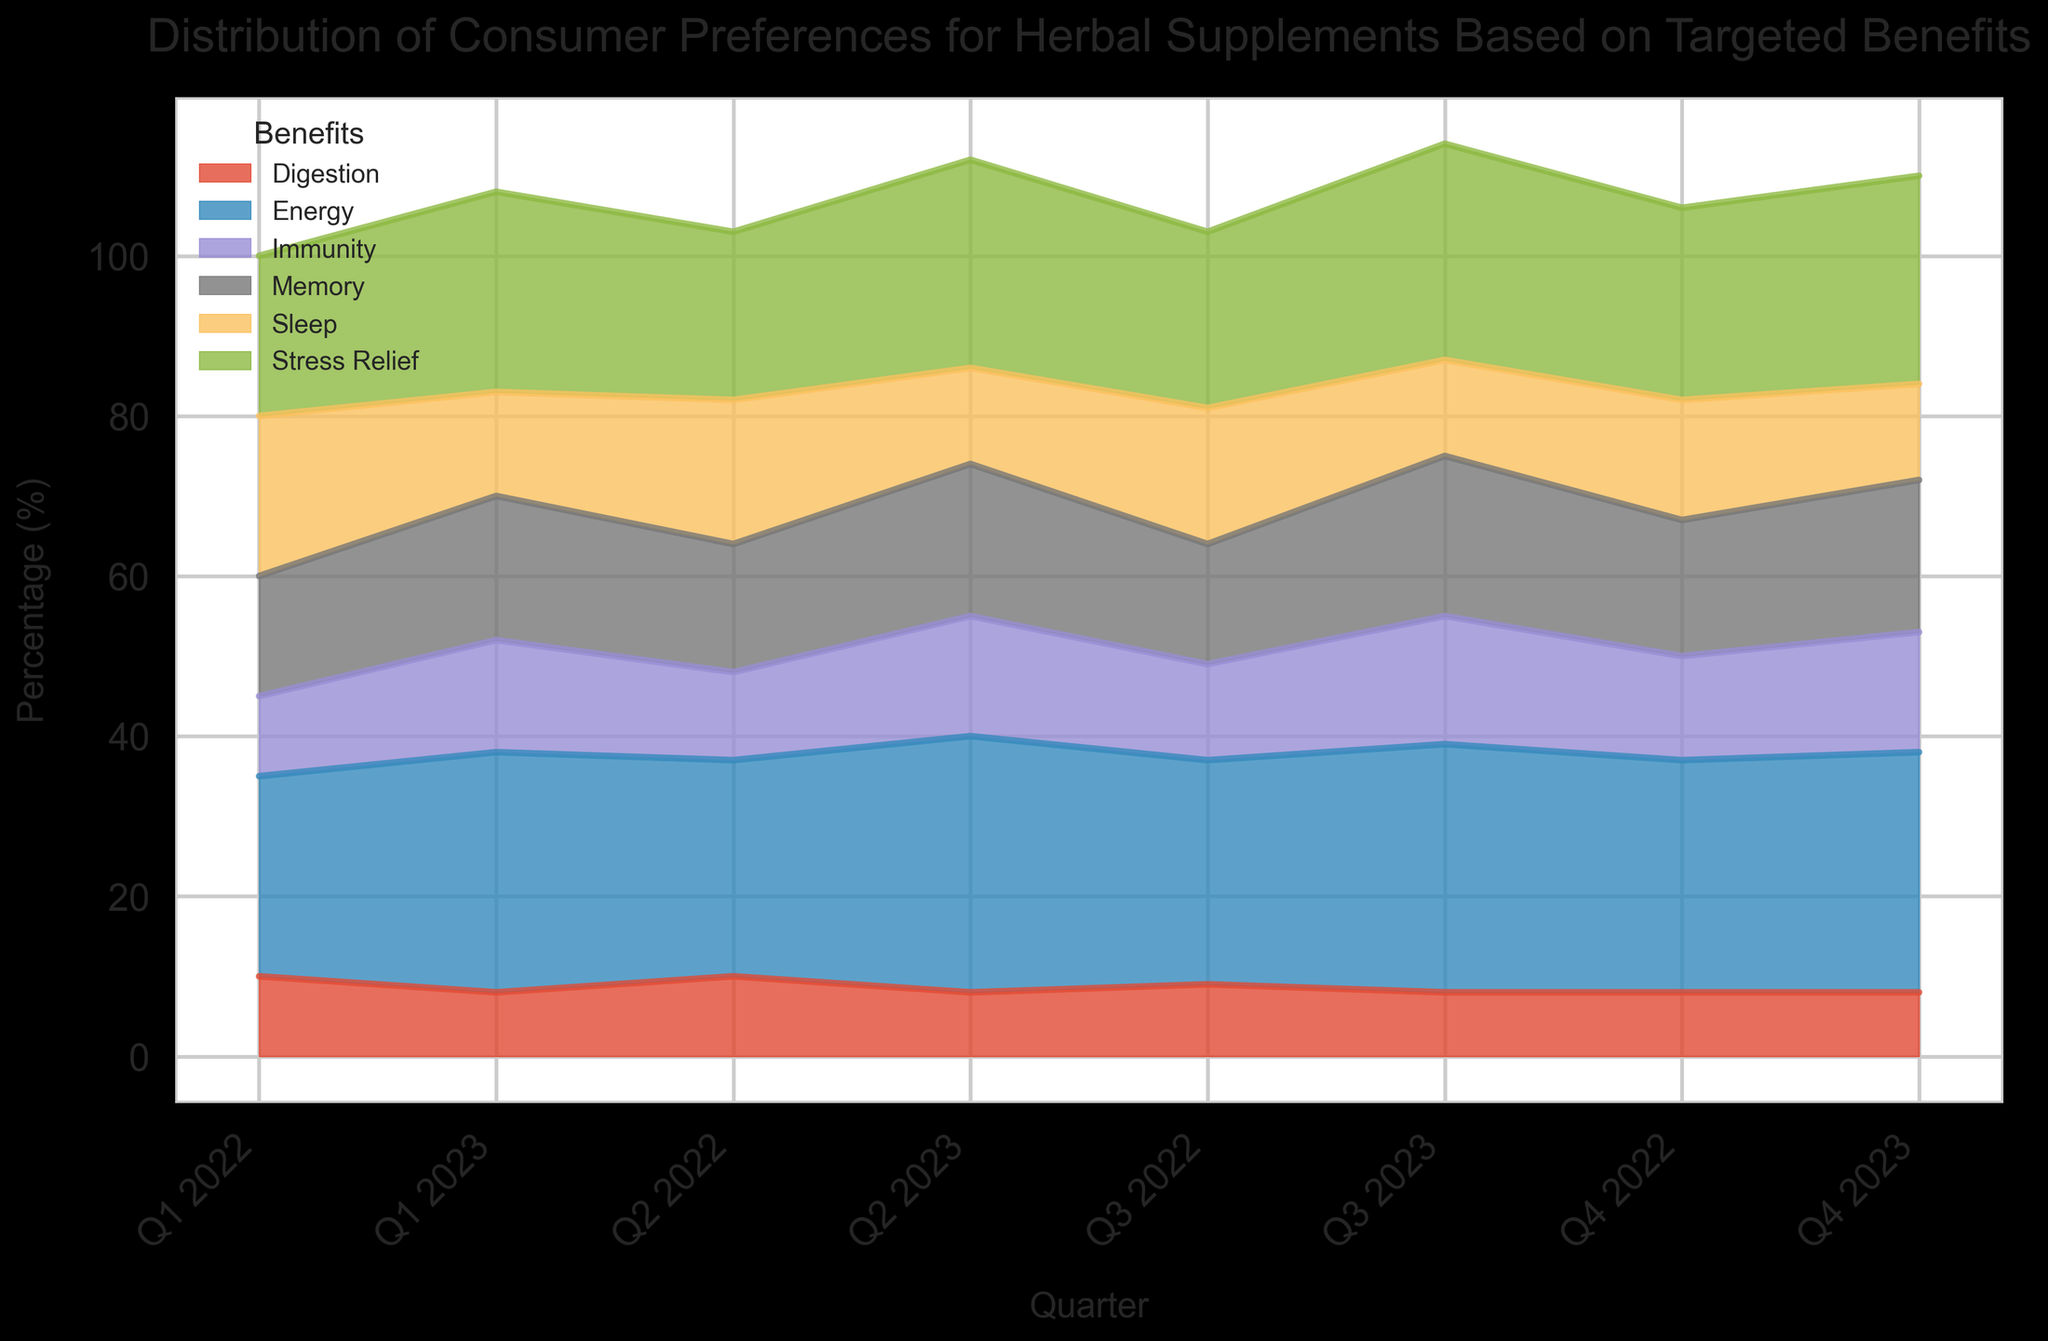What is the trend in consumer preference for memory-boosting supplements from Q1 2022 to Q4 2023? The preference for memory-boosting supplements shows a generally increasing trend, starting from 15% in Q1 2022 and reaching a peak of 20% in Q3 2023, before slightly decreasing to 19% in Q4 2023
Answer: Increasing trend Which benefit showed the highest preference in Q2 2023? In Q2 2023, the benefit with the highest consumer preference was Energy, with a percentage of 32%
Answer: Energy Compare the preference for Stress Relief and Sleep supplements in Q4 2022. Which one was more popular? To compare, we check the values for Q4 2022: Stress Relief had a preference of 24%, while Sleep had a preference of 15%. Stress Relief is more popular.
Answer: Stress Relief By how much did the consumer preference for immunity-boosting supplements change from Q1 2022 to Q4 2022? The preference for immunity-boosting supplements increased from 10% in Q1 2022 to 13% in Q4 2022. This is a change of 13% - 10% = 3%
Answer: 3% What is the average preference for digestion supplements across all quarters? The percentages across all quarters are 10%, 10%, 9%, 8%, 8%, 8%, 8%, 8%. The average is (10 + 10 + 9 + 8 + 8 + 8 + 8 + 8) / 8 = 8.625%.
Answer: 8.625% Which benefit(s) showed a constant preference over the last three quarters of 2023? By observing the last three quarters of 2023 (Q2, Q3, Q4), Digestion stayed constant at 8%, and Sleep stayed constant at 12%.
Answer: Digestion, Sleep What was the difference in consumer preference for energy-boosting supplements between Q4 2022 and Q1 2023? In Q4 2022, energy-boosting supplements had a preference of 29%, and in Q1 2023, they had a preference of 30%. The difference is 30% - 29% = 1%
Answer: 1% Which benefit showed the most significant increase in preference from Q1 2022 to Q2 2022? From Q1 2022 to Q2 2022, Energy increased from 25% to 27%, an increase of 2%; Memory increased from 15% to 16%, an increase of 1%; Stress Relief increased from 20% to 21%, an increase of 1%; Immunity increased from 10% to 11%, an increase of 1%; Digestion remained the same; Sleep decreased. Therefore, Energy showed the most significant increase.
Answer: Energy 